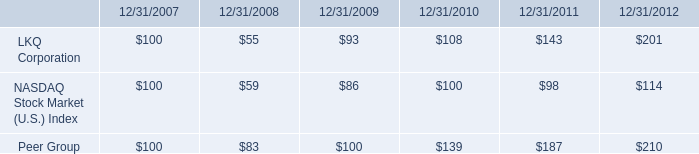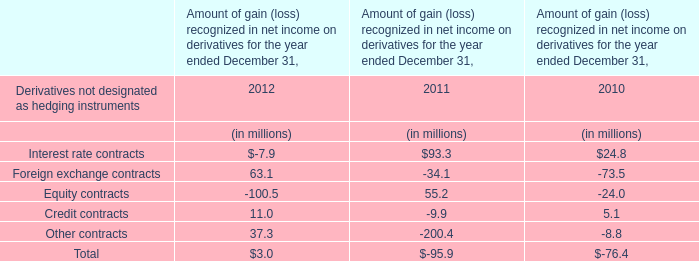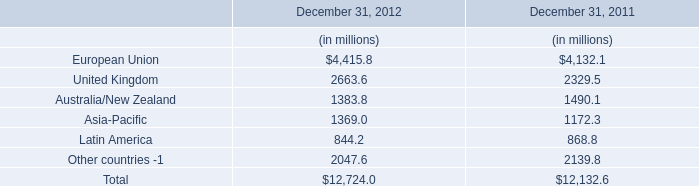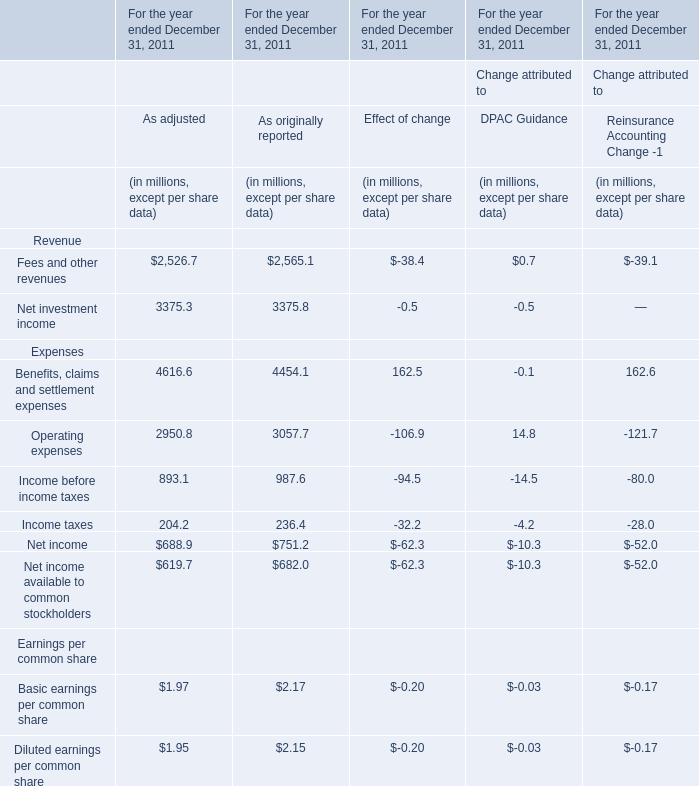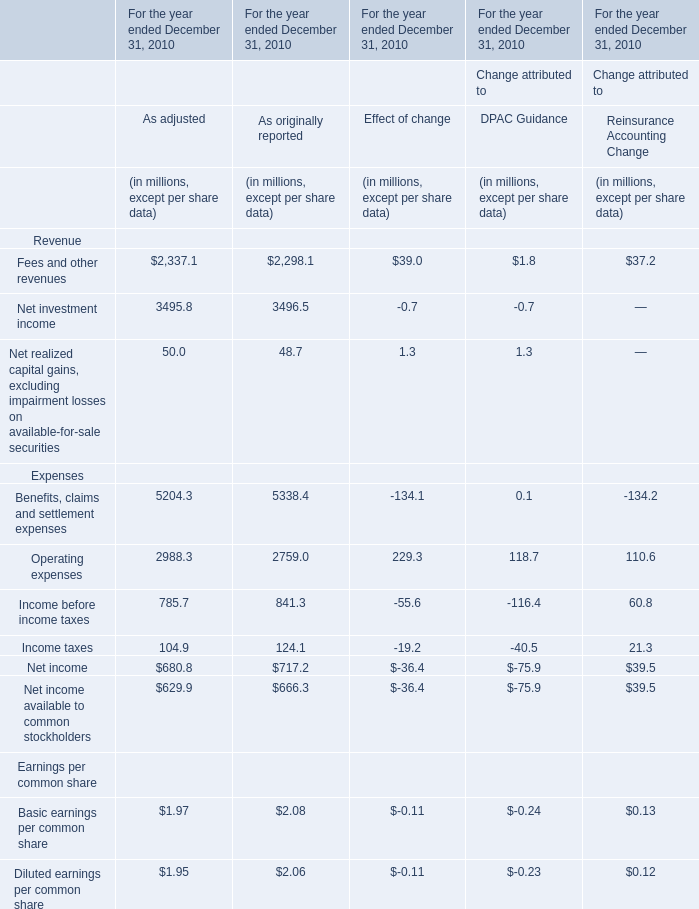What was the average of the Income before income taxes in the year where Fees and other revenues is positive for As adjusted? (in million) 
Computations: (893.1 / 1)
Answer: 893.1. 